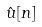Convert formula to latex. <formula><loc_0><loc_0><loc_500><loc_500>\hat { u } [ n ]</formula> 